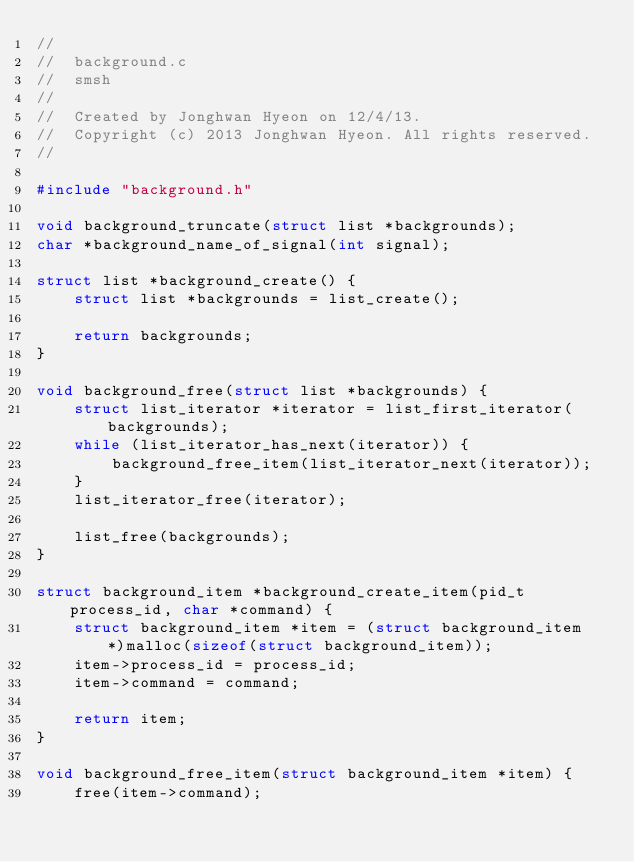Convert code to text. <code><loc_0><loc_0><loc_500><loc_500><_C_>//
//  background.c
//  smsh
//
//  Created by Jonghwan Hyeon on 12/4/13.
//  Copyright (c) 2013 Jonghwan Hyeon. All rights reserved.
//

#include "background.h"

void background_truncate(struct list *backgrounds);
char *background_name_of_signal(int signal);

struct list *background_create() {
    struct list *backgrounds = list_create();
    
    return backgrounds;
}

void background_free(struct list *backgrounds) {
    struct list_iterator *iterator = list_first_iterator(backgrounds);
    while (list_iterator_has_next(iterator)) {
        background_free_item(list_iterator_next(iterator));
    }
    list_iterator_free(iterator);

    list_free(backgrounds);
}

struct background_item *background_create_item(pid_t process_id, char *command) {
    struct background_item *item = (struct background_item *)malloc(sizeof(struct background_item));
    item->process_id = process_id;
    item->command = command;

    return item;
}

void background_free_item(struct background_item *item) {
    free(item->command);</code> 